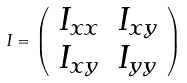Convert formula to latex. <formula><loc_0><loc_0><loc_500><loc_500>I = \left ( \begin{array} { c c } I _ { x x } & I _ { x y } \\ I _ { x y } & I _ { y y } \end{array} \right )</formula> 